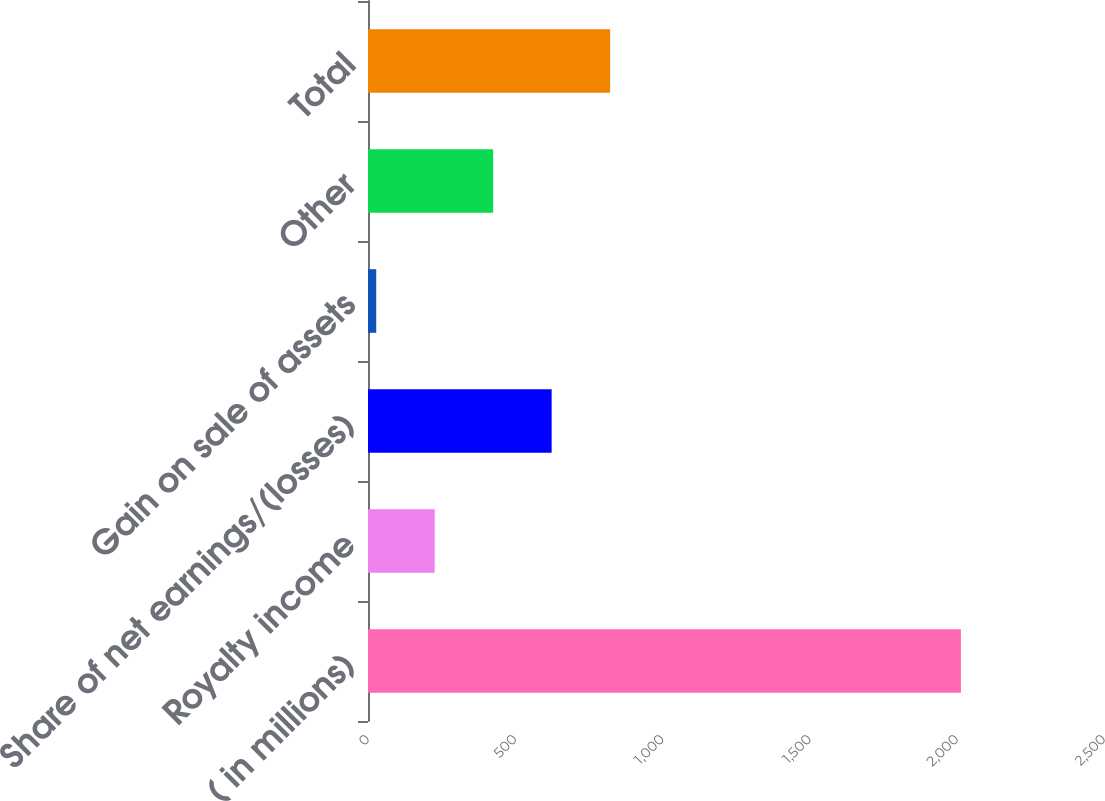Convert chart. <chart><loc_0><loc_0><loc_500><loc_500><bar_chart><fcel>( in millions)<fcel>Royalty income<fcel>Share of net earnings/(losses)<fcel>Gain on sale of assets<fcel>Other<fcel>Total<nl><fcel>2014<fcel>226.6<fcel>623.8<fcel>28<fcel>425.2<fcel>822.4<nl></chart> 